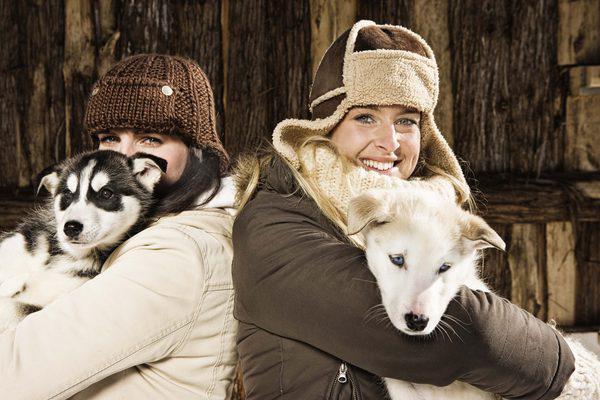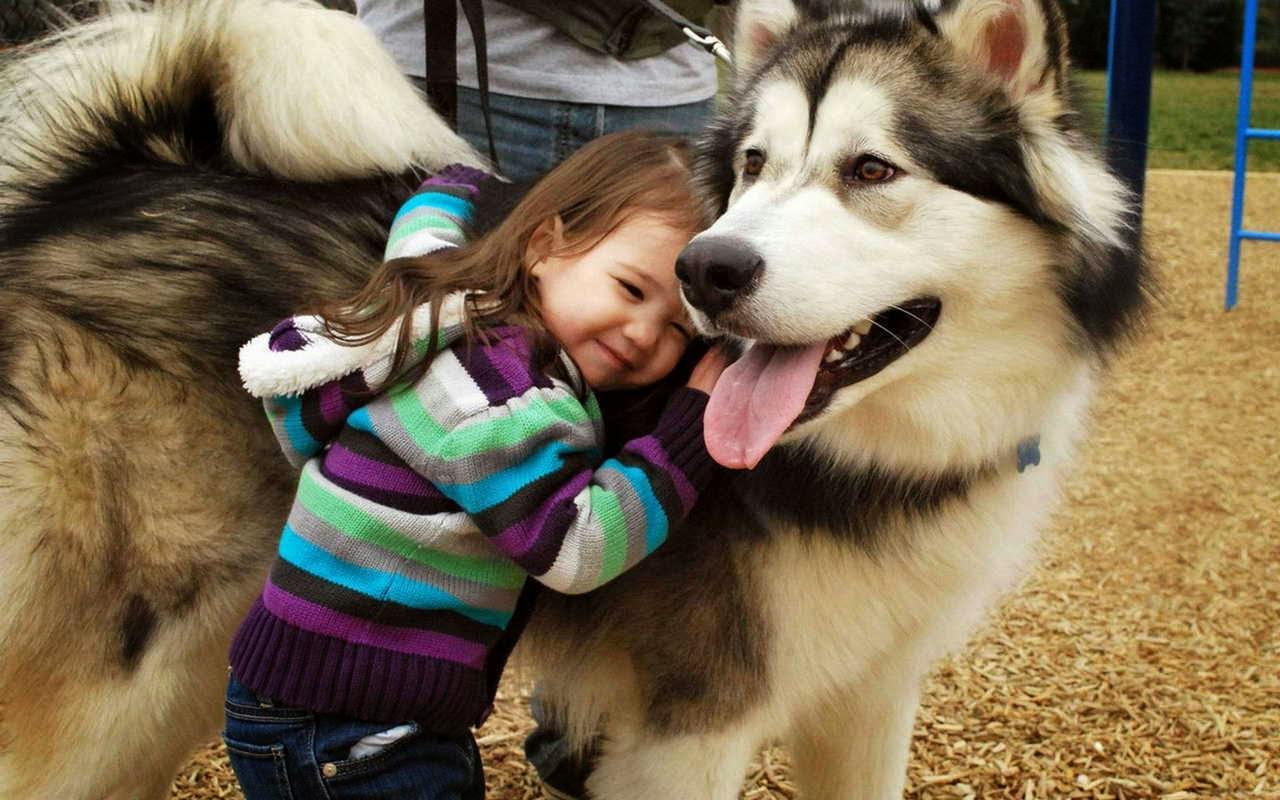The first image is the image on the left, the second image is the image on the right. Given the left and right images, does the statement "In the right image, a little girl is hugging a big dog and laying the side of her head against it." hold true? Answer yes or no. Yes. The first image is the image on the left, the second image is the image on the right. Examine the images to the left and right. Is the description "The left and right image contains the same number of dogs." accurate? Answer yes or no. No. 